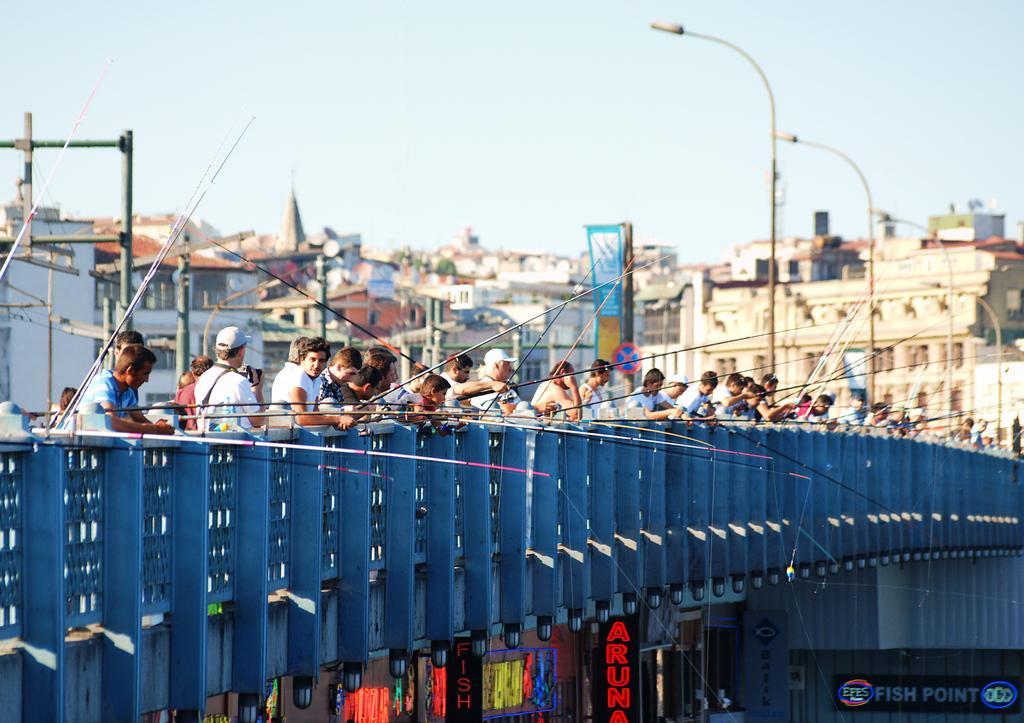Can you describe this image briefly? In this image, there are a few people. Among them, some people are holding some objects. We can see the fence. We can also see some poles, boards with text. We can also see a few buildings. We can also see the sky and a signboard. 